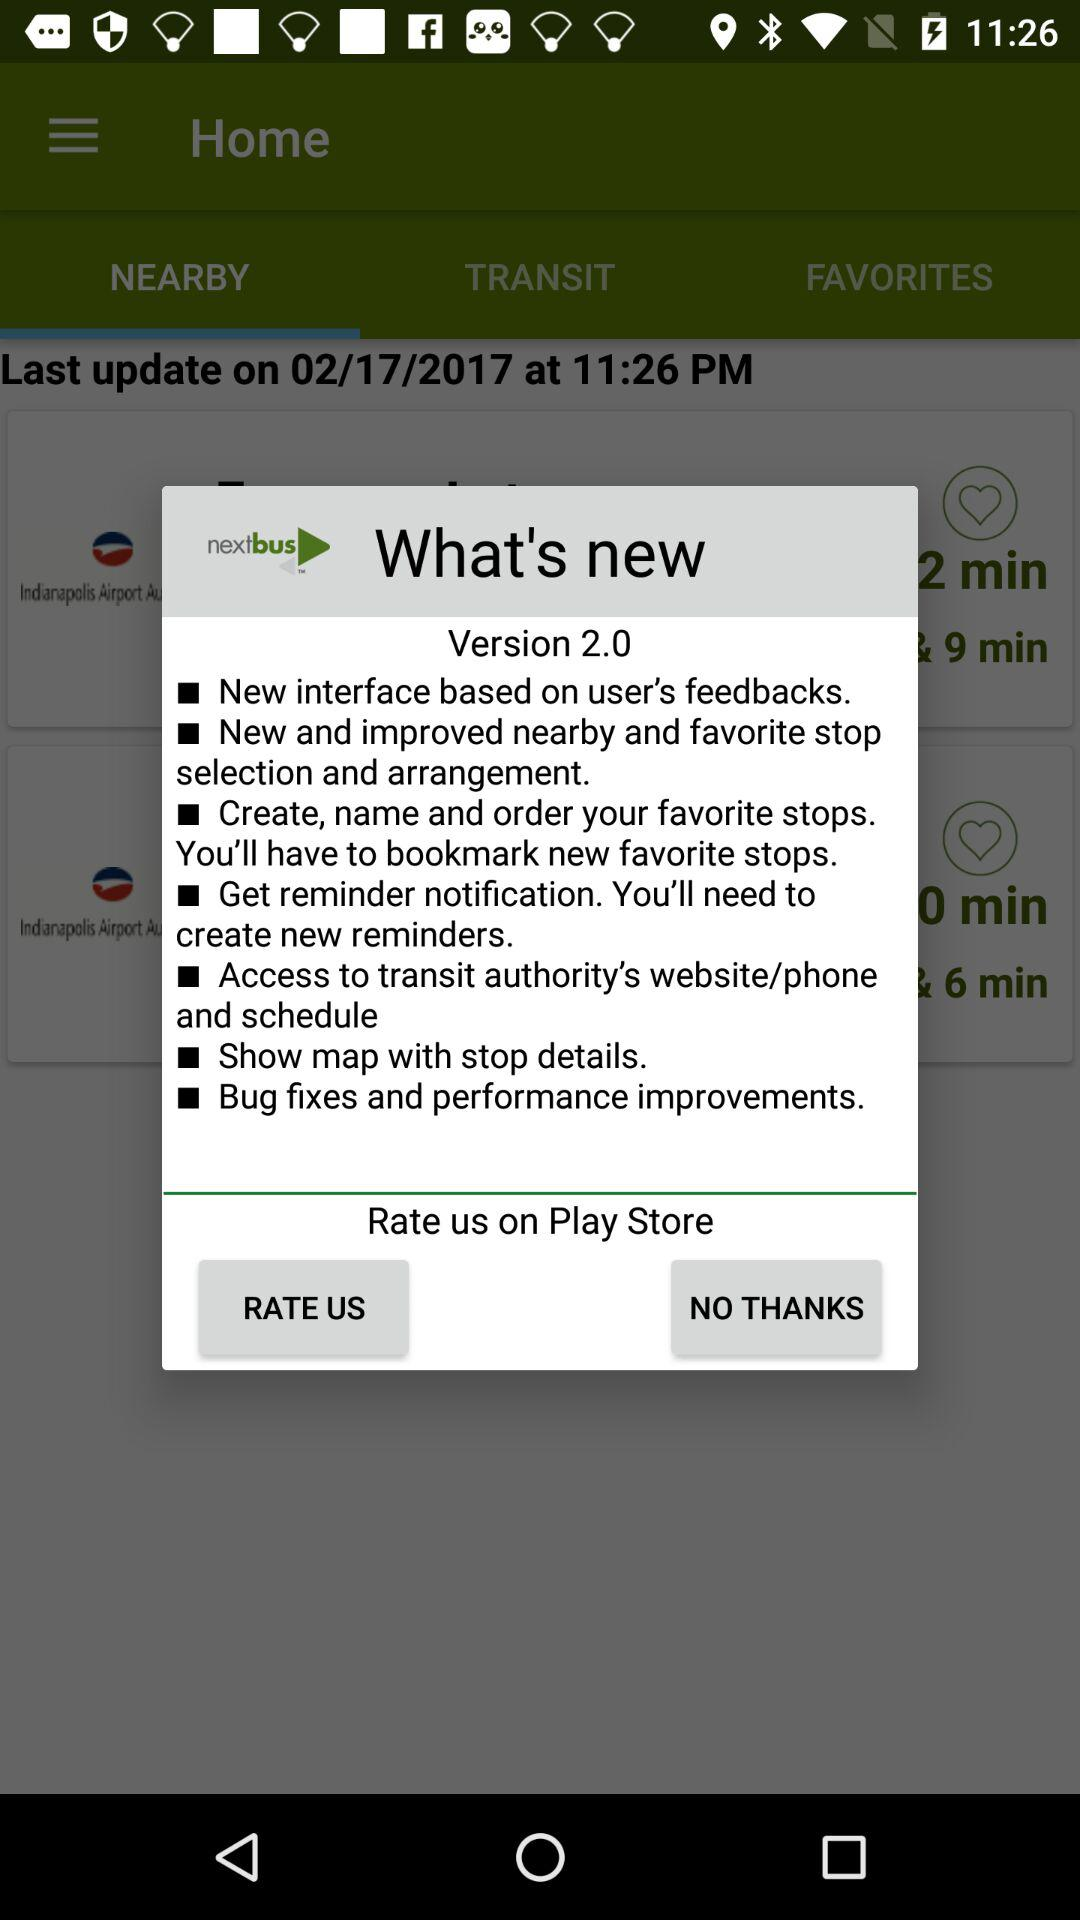When was it last updated? It was last updated on February 2, 2017. 